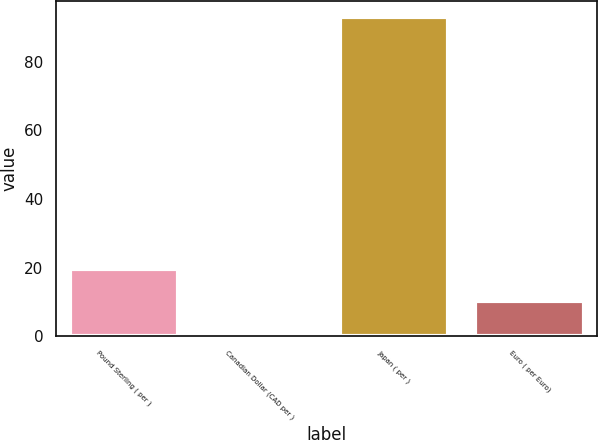Convert chart. <chart><loc_0><loc_0><loc_500><loc_500><bar_chart><fcel>Pound Sterling ( per )<fcel>Canadian Dollar (CAD per )<fcel>Japan ( per )<fcel>Euro ( per Euro)<nl><fcel>19.45<fcel>1.05<fcel>93.03<fcel>10.25<nl></chart> 